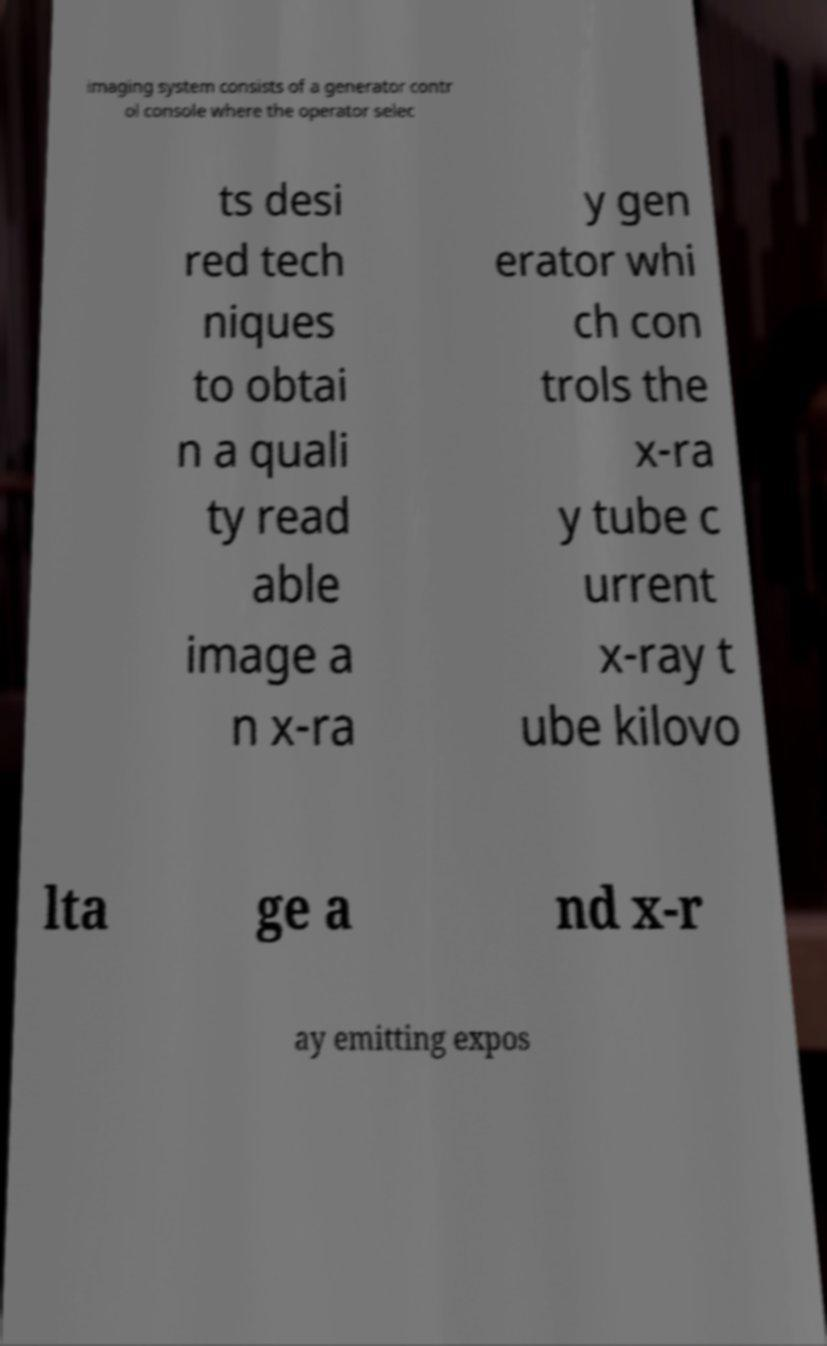There's text embedded in this image that I need extracted. Can you transcribe it verbatim? imaging system consists of a generator contr ol console where the operator selec ts desi red tech niques to obtai n a quali ty read able image a n x-ra y gen erator whi ch con trols the x-ra y tube c urrent x-ray t ube kilovo lta ge a nd x-r ay emitting expos 